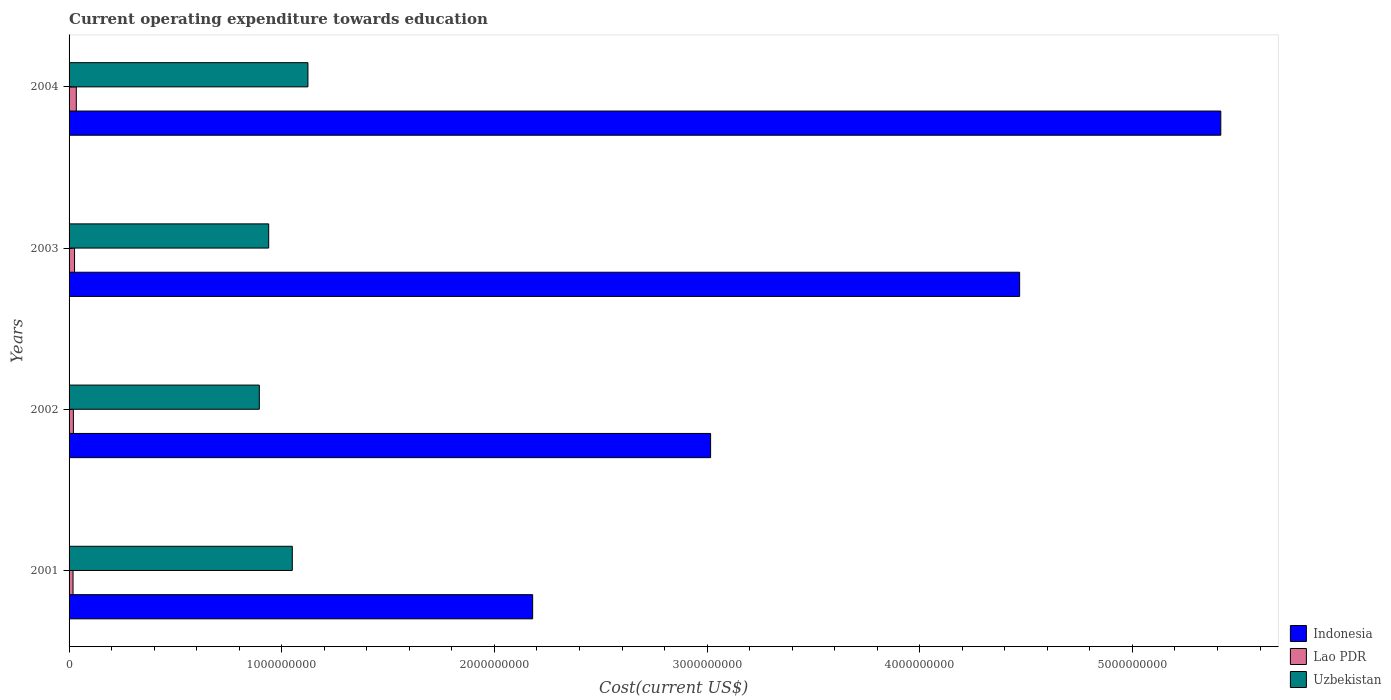Are the number of bars per tick equal to the number of legend labels?
Make the answer very short. Yes. How many bars are there on the 3rd tick from the bottom?
Give a very brief answer. 3. What is the label of the 1st group of bars from the top?
Your answer should be compact. 2004. In how many cases, is the number of bars for a given year not equal to the number of legend labels?
Offer a very short reply. 0. What is the expenditure towards education in Indonesia in 2002?
Keep it short and to the point. 3.02e+09. Across all years, what is the maximum expenditure towards education in Uzbekistan?
Provide a succinct answer. 1.12e+09. Across all years, what is the minimum expenditure towards education in Uzbekistan?
Offer a very short reply. 8.95e+08. What is the total expenditure towards education in Lao PDR in the graph?
Your answer should be compact. 9.88e+07. What is the difference between the expenditure towards education in Lao PDR in 2003 and that in 2004?
Provide a succinct answer. -8.26e+06. What is the difference between the expenditure towards education in Lao PDR in 2001 and the expenditure towards education in Uzbekistan in 2003?
Your answer should be compact. -9.20e+08. What is the average expenditure towards education in Uzbekistan per year?
Keep it short and to the point. 1.00e+09. In the year 2003, what is the difference between the expenditure towards education in Uzbekistan and expenditure towards education in Lao PDR?
Keep it short and to the point. 9.13e+08. What is the ratio of the expenditure towards education in Indonesia in 2003 to that in 2004?
Your answer should be compact. 0.83. Is the expenditure towards education in Lao PDR in 2002 less than that in 2003?
Provide a short and direct response. Yes. What is the difference between the highest and the second highest expenditure towards education in Lao PDR?
Give a very brief answer. 8.26e+06. What is the difference between the highest and the lowest expenditure towards education in Uzbekistan?
Make the answer very short. 2.29e+08. In how many years, is the expenditure towards education in Indonesia greater than the average expenditure towards education in Indonesia taken over all years?
Provide a short and direct response. 2. What does the 1st bar from the top in 2004 represents?
Provide a succinct answer. Uzbekistan. What does the 1st bar from the bottom in 2002 represents?
Provide a succinct answer. Indonesia. Is it the case that in every year, the sum of the expenditure towards education in Uzbekistan and expenditure towards education in Lao PDR is greater than the expenditure towards education in Indonesia?
Offer a very short reply. No. How many bars are there?
Offer a very short reply. 12. How many years are there in the graph?
Offer a very short reply. 4. Does the graph contain any zero values?
Give a very brief answer. No. Does the graph contain grids?
Provide a short and direct response. No. Where does the legend appear in the graph?
Make the answer very short. Bottom right. How are the legend labels stacked?
Provide a succinct answer. Vertical. What is the title of the graph?
Your answer should be compact. Current operating expenditure towards education. What is the label or title of the X-axis?
Provide a succinct answer. Cost(current US$). What is the label or title of the Y-axis?
Provide a short and direct response. Years. What is the Cost(current US$) in Indonesia in 2001?
Ensure brevity in your answer.  2.18e+09. What is the Cost(current US$) of Lao PDR in 2001?
Ensure brevity in your answer.  1.87e+07. What is the Cost(current US$) in Uzbekistan in 2001?
Provide a succinct answer. 1.05e+09. What is the Cost(current US$) in Indonesia in 2002?
Give a very brief answer. 3.02e+09. What is the Cost(current US$) of Lao PDR in 2002?
Give a very brief answer. 2.03e+07. What is the Cost(current US$) in Uzbekistan in 2002?
Offer a very short reply. 8.95e+08. What is the Cost(current US$) of Indonesia in 2003?
Provide a short and direct response. 4.47e+09. What is the Cost(current US$) of Lao PDR in 2003?
Your answer should be compact. 2.58e+07. What is the Cost(current US$) in Uzbekistan in 2003?
Provide a short and direct response. 9.39e+08. What is the Cost(current US$) in Indonesia in 2004?
Offer a very short reply. 5.42e+09. What is the Cost(current US$) in Lao PDR in 2004?
Your response must be concise. 3.40e+07. What is the Cost(current US$) of Uzbekistan in 2004?
Keep it short and to the point. 1.12e+09. Across all years, what is the maximum Cost(current US$) in Indonesia?
Make the answer very short. 5.42e+09. Across all years, what is the maximum Cost(current US$) of Lao PDR?
Offer a very short reply. 3.40e+07. Across all years, what is the maximum Cost(current US$) in Uzbekistan?
Give a very brief answer. 1.12e+09. Across all years, what is the minimum Cost(current US$) in Indonesia?
Provide a short and direct response. 2.18e+09. Across all years, what is the minimum Cost(current US$) in Lao PDR?
Ensure brevity in your answer.  1.87e+07. Across all years, what is the minimum Cost(current US$) in Uzbekistan?
Offer a very short reply. 8.95e+08. What is the total Cost(current US$) of Indonesia in the graph?
Provide a succinct answer. 1.51e+1. What is the total Cost(current US$) of Lao PDR in the graph?
Give a very brief answer. 9.88e+07. What is the total Cost(current US$) of Uzbekistan in the graph?
Ensure brevity in your answer.  4.01e+09. What is the difference between the Cost(current US$) of Indonesia in 2001 and that in 2002?
Keep it short and to the point. -8.37e+08. What is the difference between the Cost(current US$) of Lao PDR in 2001 and that in 2002?
Offer a terse response. -1.63e+06. What is the difference between the Cost(current US$) of Uzbekistan in 2001 and that in 2002?
Give a very brief answer. 1.55e+08. What is the difference between the Cost(current US$) in Indonesia in 2001 and that in 2003?
Ensure brevity in your answer.  -2.29e+09. What is the difference between the Cost(current US$) of Lao PDR in 2001 and that in 2003?
Your answer should be very brief. -7.09e+06. What is the difference between the Cost(current US$) of Uzbekistan in 2001 and that in 2003?
Your answer should be compact. 1.11e+08. What is the difference between the Cost(current US$) of Indonesia in 2001 and that in 2004?
Make the answer very short. -3.24e+09. What is the difference between the Cost(current US$) in Lao PDR in 2001 and that in 2004?
Provide a succinct answer. -1.53e+07. What is the difference between the Cost(current US$) in Uzbekistan in 2001 and that in 2004?
Provide a succinct answer. -7.36e+07. What is the difference between the Cost(current US$) of Indonesia in 2002 and that in 2003?
Offer a very short reply. -1.45e+09. What is the difference between the Cost(current US$) in Lao PDR in 2002 and that in 2003?
Provide a short and direct response. -5.46e+06. What is the difference between the Cost(current US$) of Uzbekistan in 2002 and that in 2003?
Provide a short and direct response. -4.40e+07. What is the difference between the Cost(current US$) in Indonesia in 2002 and that in 2004?
Your answer should be compact. -2.40e+09. What is the difference between the Cost(current US$) of Lao PDR in 2002 and that in 2004?
Your answer should be compact. -1.37e+07. What is the difference between the Cost(current US$) of Uzbekistan in 2002 and that in 2004?
Give a very brief answer. -2.29e+08. What is the difference between the Cost(current US$) in Indonesia in 2003 and that in 2004?
Offer a very short reply. -9.46e+08. What is the difference between the Cost(current US$) in Lao PDR in 2003 and that in 2004?
Offer a terse response. -8.26e+06. What is the difference between the Cost(current US$) in Uzbekistan in 2003 and that in 2004?
Keep it short and to the point. -1.85e+08. What is the difference between the Cost(current US$) of Indonesia in 2001 and the Cost(current US$) of Lao PDR in 2002?
Keep it short and to the point. 2.16e+09. What is the difference between the Cost(current US$) in Indonesia in 2001 and the Cost(current US$) in Uzbekistan in 2002?
Your answer should be compact. 1.29e+09. What is the difference between the Cost(current US$) of Lao PDR in 2001 and the Cost(current US$) of Uzbekistan in 2002?
Ensure brevity in your answer.  -8.76e+08. What is the difference between the Cost(current US$) of Indonesia in 2001 and the Cost(current US$) of Lao PDR in 2003?
Ensure brevity in your answer.  2.15e+09. What is the difference between the Cost(current US$) of Indonesia in 2001 and the Cost(current US$) of Uzbekistan in 2003?
Your answer should be very brief. 1.24e+09. What is the difference between the Cost(current US$) in Lao PDR in 2001 and the Cost(current US$) in Uzbekistan in 2003?
Your answer should be compact. -9.20e+08. What is the difference between the Cost(current US$) of Indonesia in 2001 and the Cost(current US$) of Lao PDR in 2004?
Give a very brief answer. 2.15e+09. What is the difference between the Cost(current US$) in Indonesia in 2001 and the Cost(current US$) in Uzbekistan in 2004?
Offer a terse response. 1.06e+09. What is the difference between the Cost(current US$) in Lao PDR in 2001 and the Cost(current US$) in Uzbekistan in 2004?
Offer a terse response. -1.10e+09. What is the difference between the Cost(current US$) in Indonesia in 2002 and the Cost(current US$) in Lao PDR in 2003?
Provide a short and direct response. 2.99e+09. What is the difference between the Cost(current US$) in Indonesia in 2002 and the Cost(current US$) in Uzbekistan in 2003?
Make the answer very short. 2.08e+09. What is the difference between the Cost(current US$) in Lao PDR in 2002 and the Cost(current US$) in Uzbekistan in 2003?
Make the answer very short. -9.18e+08. What is the difference between the Cost(current US$) of Indonesia in 2002 and the Cost(current US$) of Lao PDR in 2004?
Your answer should be very brief. 2.98e+09. What is the difference between the Cost(current US$) in Indonesia in 2002 and the Cost(current US$) in Uzbekistan in 2004?
Offer a terse response. 1.89e+09. What is the difference between the Cost(current US$) in Lao PDR in 2002 and the Cost(current US$) in Uzbekistan in 2004?
Provide a short and direct response. -1.10e+09. What is the difference between the Cost(current US$) of Indonesia in 2003 and the Cost(current US$) of Lao PDR in 2004?
Your answer should be very brief. 4.44e+09. What is the difference between the Cost(current US$) of Indonesia in 2003 and the Cost(current US$) of Uzbekistan in 2004?
Offer a very short reply. 3.35e+09. What is the difference between the Cost(current US$) of Lao PDR in 2003 and the Cost(current US$) of Uzbekistan in 2004?
Give a very brief answer. -1.10e+09. What is the average Cost(current US$) in Indonesia per year?
Keep it short and to the point. 3.77e+09. What is the average Cost(current US$) in Lao PDR per year?
Offer a very short reply. 2.47e+07. What is the average Cost(current US$) in Uzbekistan per year?
Offer a very short reply. 1.00e+09. In the year 2001, what is the difference between the Cost(current US$) in Indonesia and Cost(current US$) in Lao PDR?
Ensure brevity in your answer.  2.16e+09. In the year 2001, what is the difference between the Cost(current US$) of Indonesia and Cost(current US$) of Uzbekistan?
Your answer should be very brief. 1.13e+09. In the year 2001, what is the difference between the Cost(current US$) of Lao PDR and Cost(current US$) of Uzbekistan?
Offer a terse response. -1.03e+09. In the year 2002, what is the difference between the Cost(current US$) in Indonesia and Cost(current US$) in Lao PDR?
Offer a very short reply. 3.00e+09. In the year 2002, what is the difference between the Cost(current US$) in Indonesia and Cost(current US$) in Uzbekistan?
Ensure brevity in your answer.  2.12e+09. In the year 2002, what is the difference between the Cost(current US$) of Lao PDR and Cost(current US$) of Uzbekistan?
Your answer should be compact. -8.74e+08. In the year 2003, what is the difference between the Cost(current US$) in Indonesia and Cost(current US$) in Lao PDR?
Your response must be concise. 4.44e+09. In the year 2003, what is the difference between the Cost(current US$) in Indonesia and Cost(current US$) in Uzbekistan?
Your answer should be compact. 3.53e+09. In the year 2003, what is the difference between the Cost(current US$) in Lao PDR and Cost(current US$) in Uzbekistan?
Ensure brevity in your answer.  -9.13e+08. In the year 2004, what is the difference between the Cost(current US$) of Indonesia and Cost(current US$) of Lao PDR?
Keep it short and to the point. 5.38e+09. In the year 2004, what is the difference between the Cost(current US$) in Indonesia and Cost(current US$) in Uzbekistan?
Make the answer very short. 4.29e+09. In the year 2004, what is the difference between the Cost(current US$) in Lao PDR and Cost(current US$) in Uzbekistan?
Ensure brevity in your answer.  -1.09e+09. What is the ratio of the Cost(current US$) in Indonesia in 2001 to that in 2002?
Keep it short and to the point. 0.72. What is the ratio of the Cost(current US$) in Lao PDR in 2001 to that in 2002?
Make the answer very short. 0.92. What is the ratio of the Cost(current US$) of Uzbekistan in 2001 to that in 2002?
Make the answer very short. 1.17. What is the ratio of the Cost(current US$) in Indonesia in 2001 to that in 2003?
Your answer should be very brief. 0.49. What is the ratio of the Cost(current US$) in Lao PDR in 2001 to that in 2003?
Your response must be concise. 0.73. What is the ratio of the Cost(current US$) in Uzbekistan in 2001 to that in 2003?
Ensure brevity in your answer.  1.12. What is the ratio of the Cost(current US$) in Indonesia in 2001 to that in 2004?
Provide a succinct answer. 0.4. What is the ratio of the Cost(current US$) in Lao PDR in 2001 to that in 2004?
Ensure brevity in your answer.  0.55. What is the ratio of the Cost(current US$) in Uzbekistan in 2001 to that in 2004?
Keep it short and to the point. 0.93. What is the ratio of the Cost(current US$) in Indonesia in 2002 to that in 2003?
Ensure brevity in your answer.  0.67. What is the ratio of the Cost(current US$) of Lao PDR in 2002 to that in 2003?
Give a very brief answer. 0.79. What is the ratio of the Cost(current US$) of Uzbekistan in 2002 to that in 2003?
Make the answer very short. 0.95. What is the ratio of the Cost(current US$) of Indonesia in 2002 to that in 2004?
Provide a succinct answer. 0.56. What is the ratio of the Cost(current US$) of Lao PDR in 2002 to that in 2004?
Offer a very short reply. 0.6. What is the ratio of the Cost(current US$) of Uzbekistan in 2002 to that in 2004?
Offer a very short reply. 0.8. What is the ratio of the Cost(current US$) of Indonesia in 2003 to that in 2004?
Offer a terse response. 0.83. What is the ratio of the Cost(current US$) of Lao PDR in 2003 to that in 2004?
Your answer should be compact. 0.76. What is the ratio of the Cost(current US$) of Uzbekistan in 2003 to that in 2004?
Offer a terse response. 0.84. What is the difference between the highest and the second highest Cost(current US$) of Indonesia?
Make the answer very short. 9.46e+08. What is the difference between the highest and the second highest Cost(current US$) of Lao PDR?
Give a very brief answer. 8.26e+06. What is the difference between the highest and the second highest Cost(current US$) in Uzbekistan?
Your response must be concise. 7.36e+07. What is the difference between the highest and the lowest Cost(current US$) in Indonesia?
Your answer should be very brief. 3.24e+09. What is the difference between the highest and the lowest Cost(current US$) of Lao PDR?
Provide a short and direct response. 1.53e+07. What is the difference between the highest and the lowest Cost(current US$) in Uzbekistan?
Offer a terse response. 2.29e+08. 